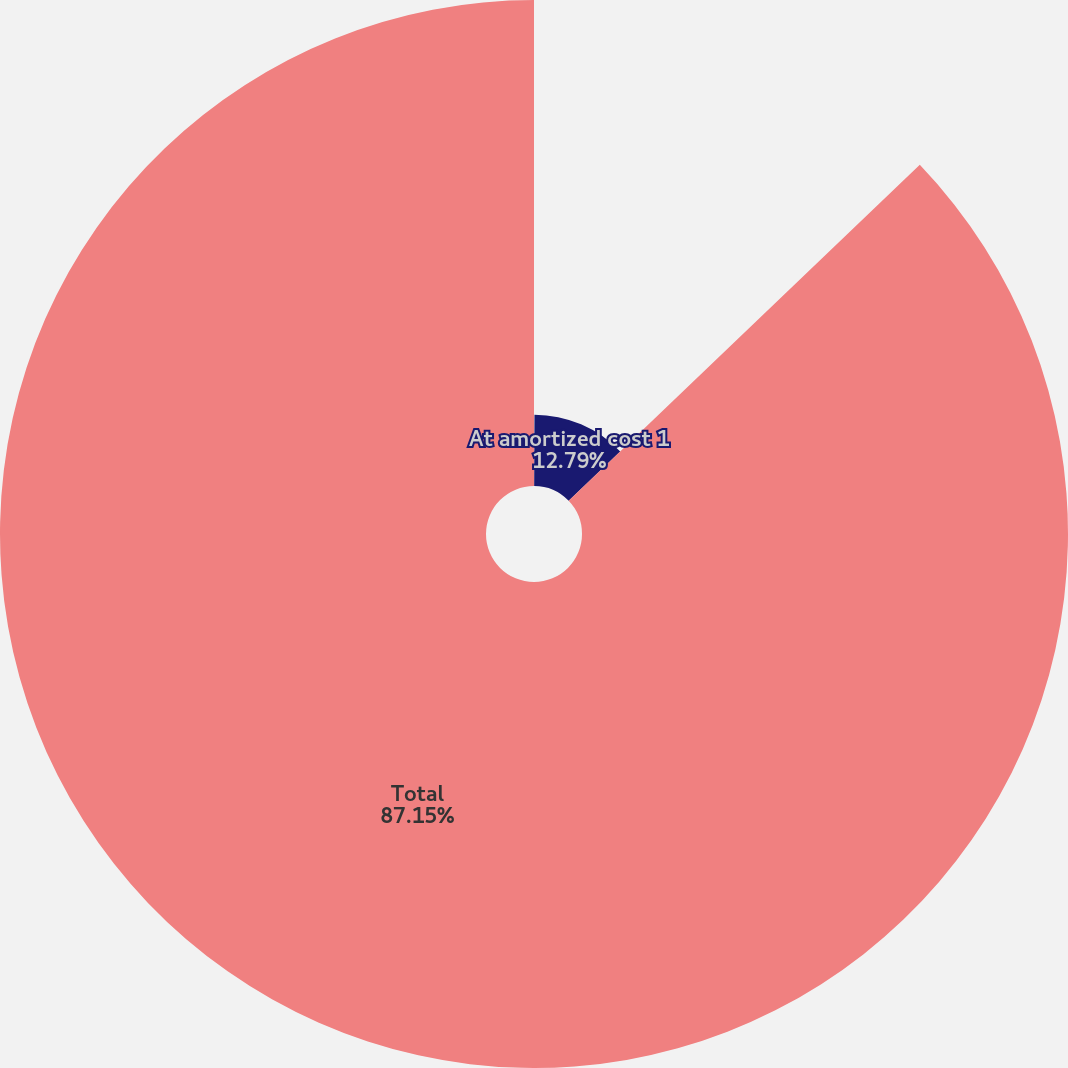Convert chart to OTSL. <chart><loc_0><loc_0><loc_500><loc_500><pie_chart><fcel>At fair value<fcel>At amortized cost 1<fcel>Total<nl><fcel>0.06%<fcel>12.79%<fcel>87.15%<nl></chart> 